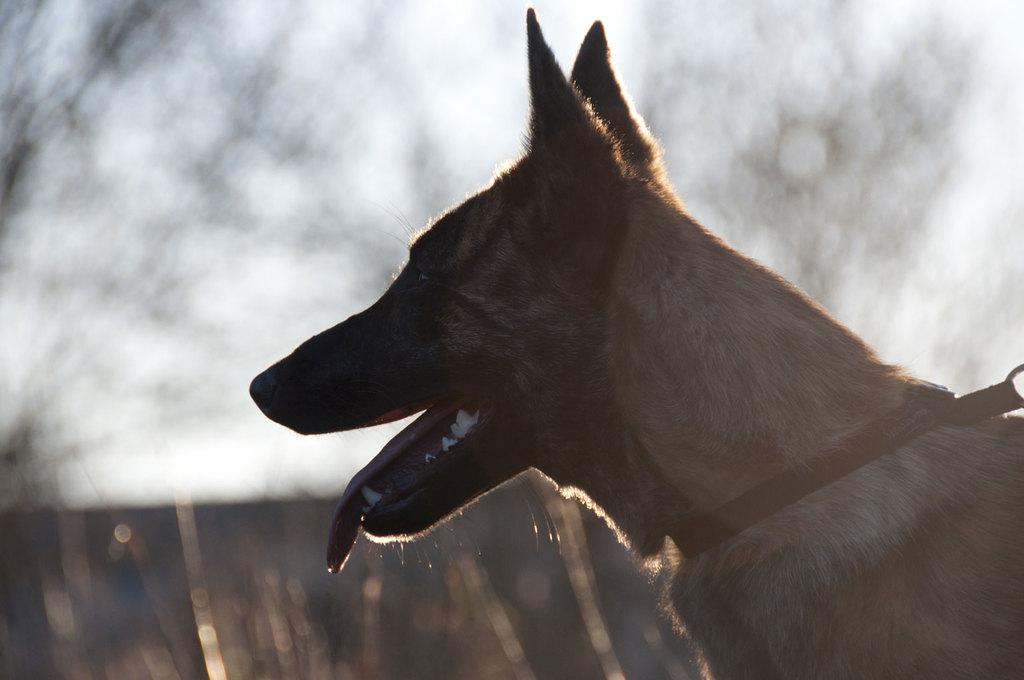What animal is present in the image? There is a dog in the picture. Can you describe the background of the image? The background of the image is blurry. How many giraffes can be seen walking in the background of the image? There are no giraffes present in the image, and the background is blurry, so it is not possible to see any animals walking. 